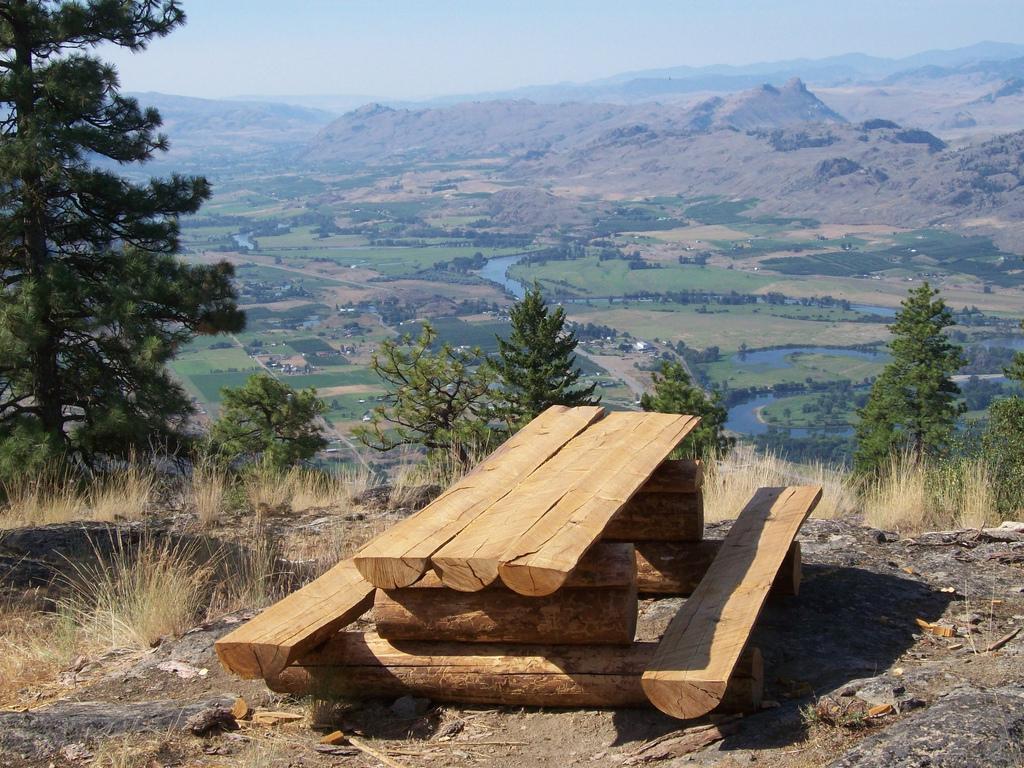Describe this image in one or two sentences. In this picture we can see wooden picnic table on the ground, grass, trees and water. In the background of the image we can see hills and sky. 